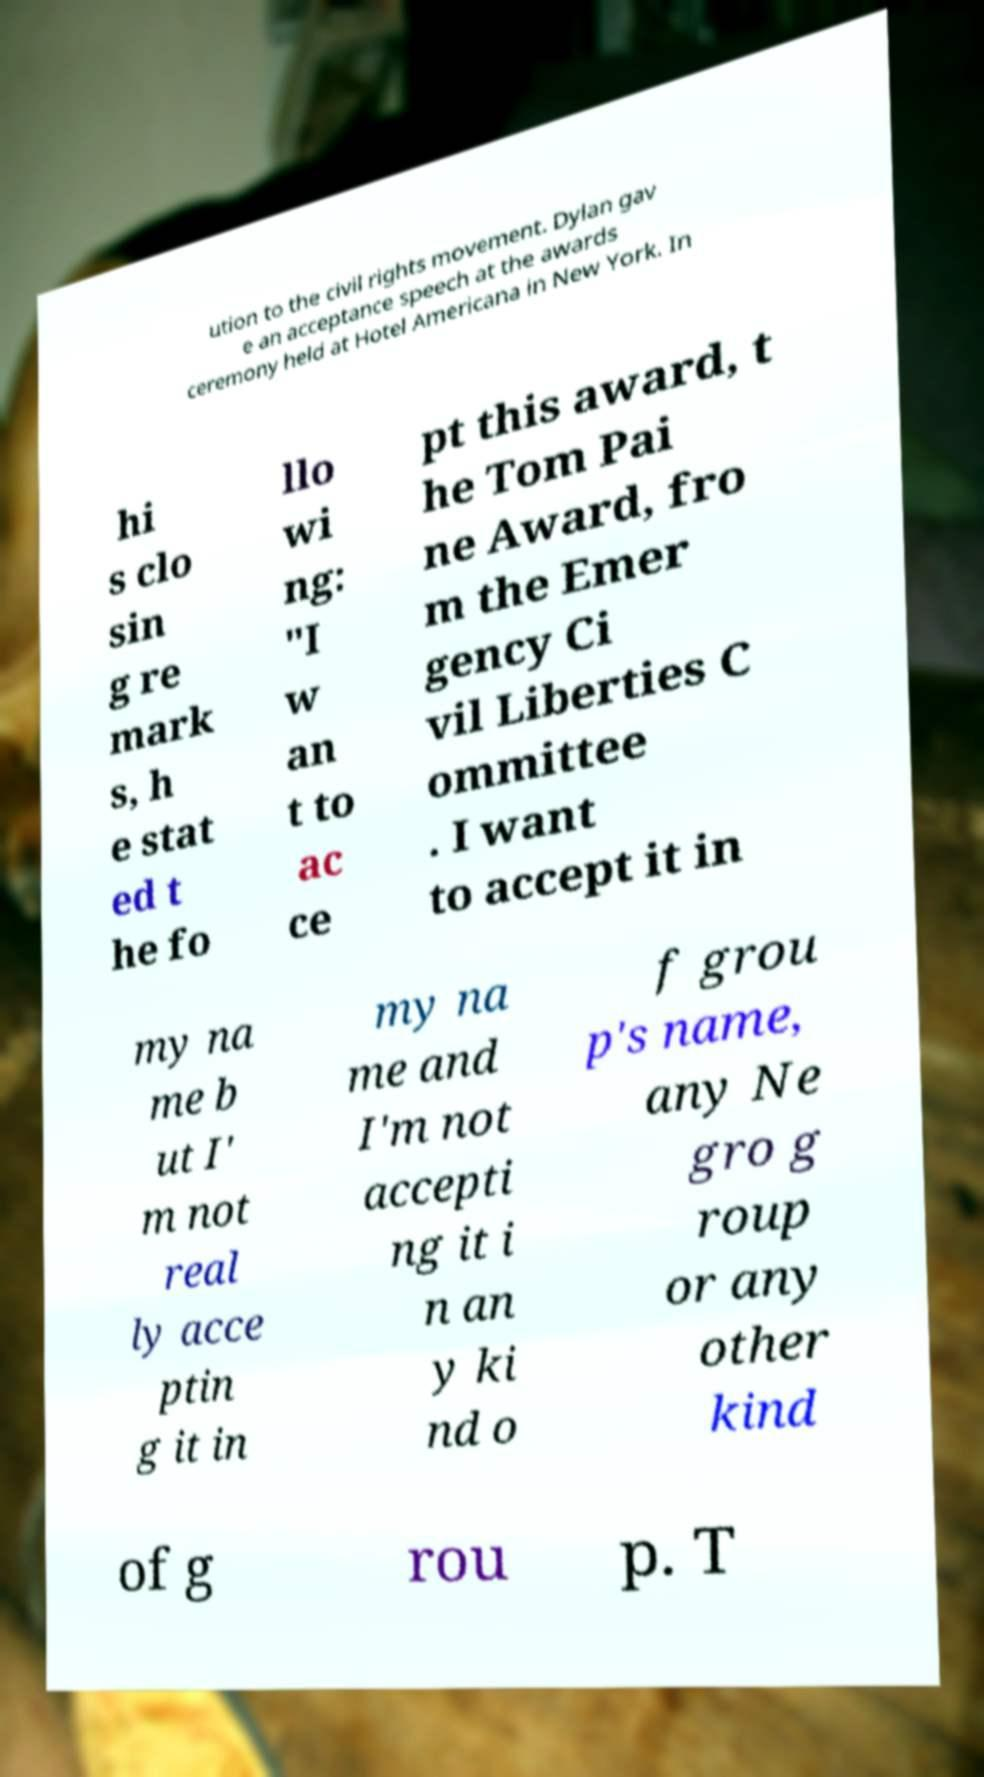Can you accurately transcribe the text from the provided image for me? ution to the civil rights movement. Dylan gav e an acceptance speech at the awards ceremony held at Hotel Americana in New York. In hi s clo sin g re mark s, h e stat ed t he fo llo wi ng: "I w an t to ac ce pt this award, t he Tom Pai ne Award, fro m the Emer gency Ci vil Liberties C ommittee . I want to accept it in my na me b ut I' m not real ly acce ptin g it in my na me and I'm not accepti ng it i n an y ki nd o f grou p's name, any Ne gro g roup or any other kind of g rou p. T 